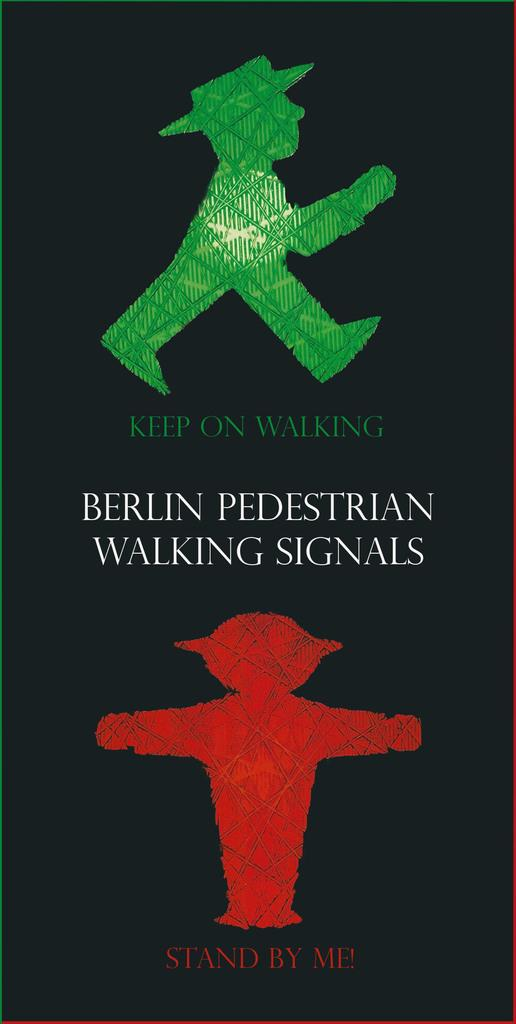What can be seen in the image related to communication or information? There is a sign board in the image. What is written or displayed on the sign board? There is text on the sign board. How does the sign board affect the skin of the people in the image? The image does not show any people, and the sign board's effect on skin is not mentioned or visible in the image. 